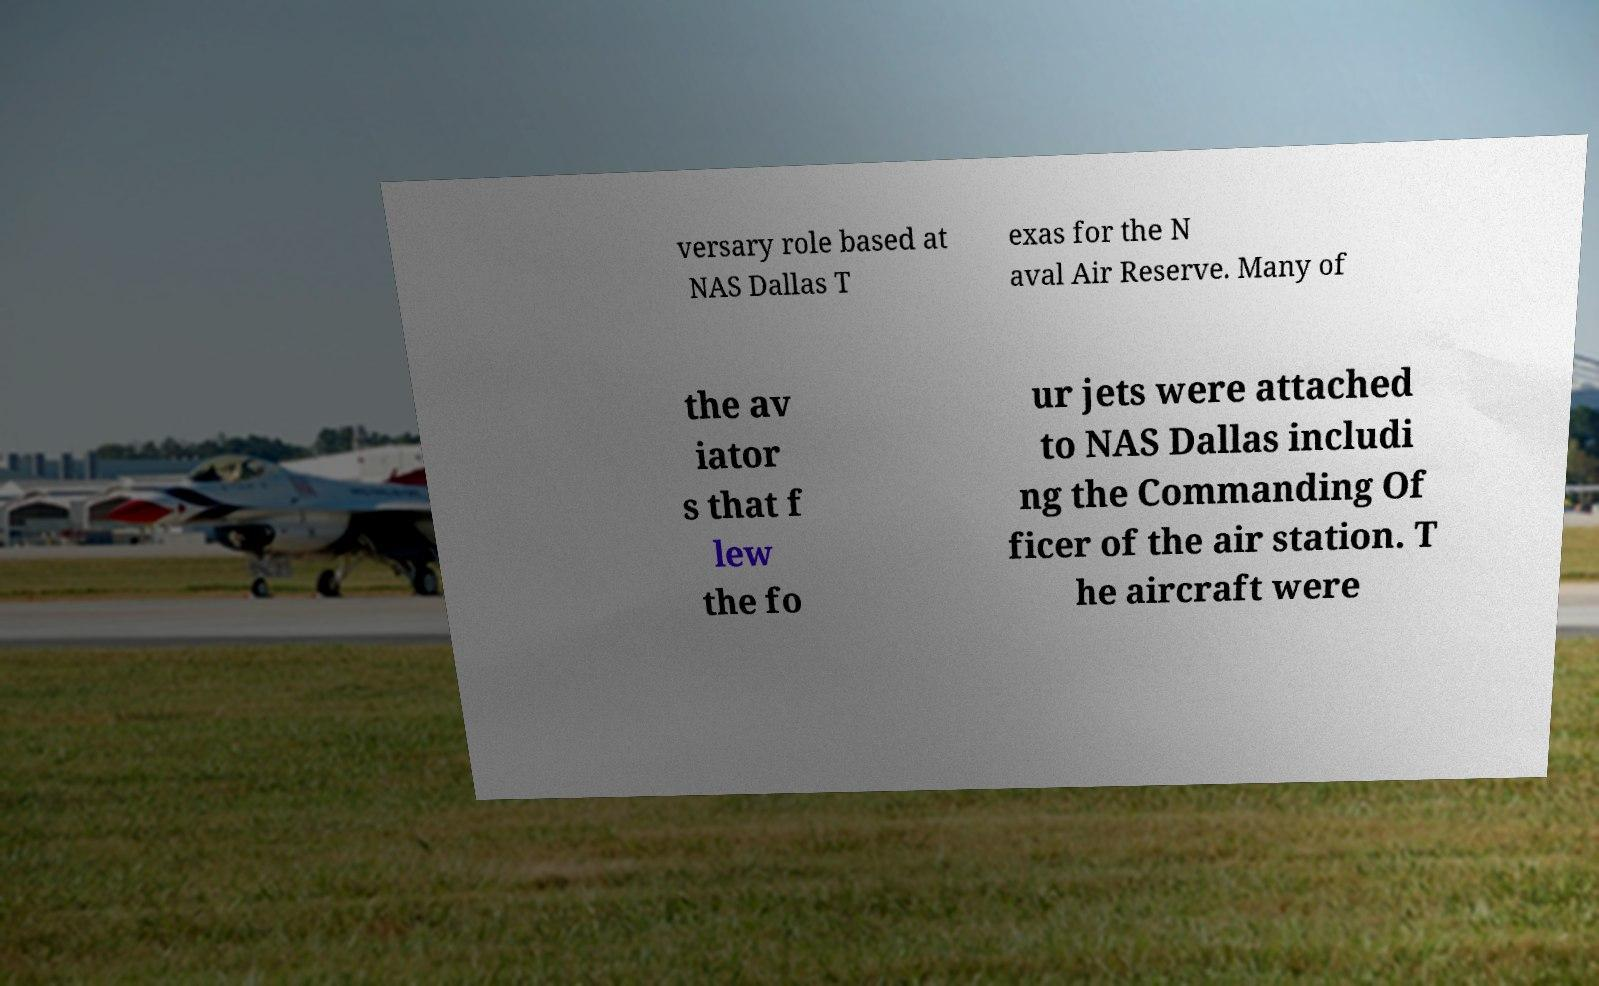Please identify and transcribe the text found in this image. versary role based at NAS Dallas T exas for the N aval Air Reserve. Many of the av iator s that f lew the fo ur jets were attached to NAS Dallas includi ng the Commanding Of ficer of the air station. T he aircraft were 